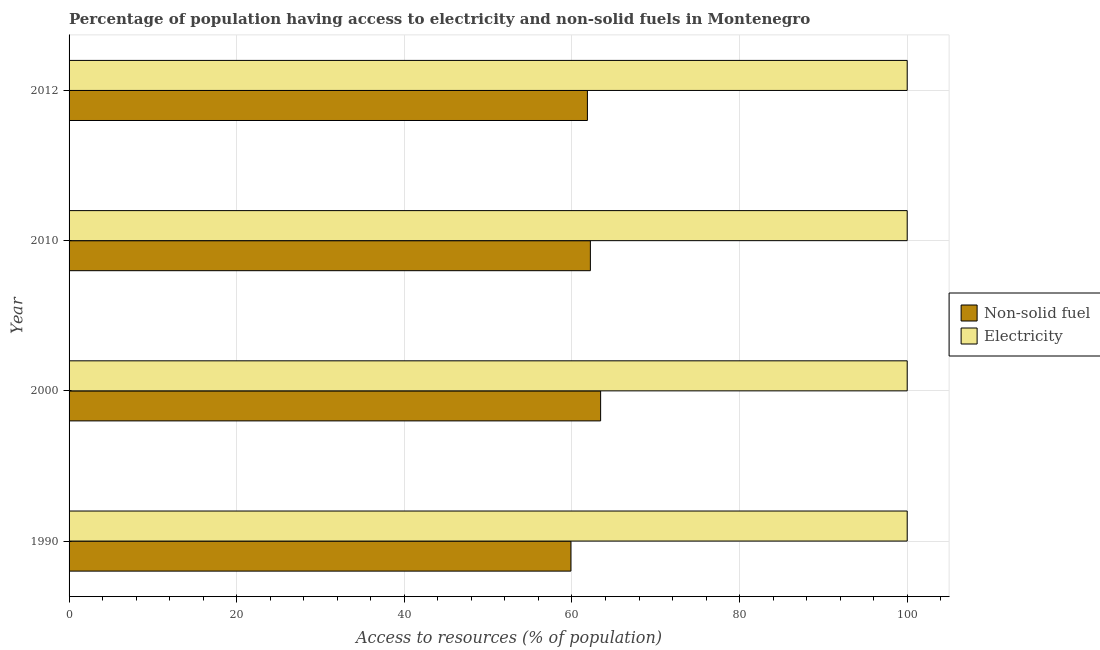Are the number of bars per tick equal to the number of legend labels?
Make the answer very short. Yes. How many bars are there on the 4th tick from the top?
Provide a succinct answer. 2. How many bars are there on the 4th tick from the bottom?
Ensure brevity in your answer.  2. What is the percentage of population having access to electricity in 2010?
Ensure brevity in your answer.  100. Across all years, what is the maximum percentage of population having access to non-solid fuel?
Ensure brevity in your answer.  63.42. Across all years, what is the minimum percentage of population having access to electricity?
Your answer should be compact. 100. What is the total percentage of population having access to electricity in the graph?
Keep it short and to the point. 400. What is the difference between the percentage of population having access to non-solid fuel in 2000 and that in 2010?
Keep it short and to the point. 1.22. What is the difference between the percentage of population having access to electricity in 2012 and the percentage of population having access to non-solid fuel in 2010?
Provide a succinct answer. 37.8. What is the average percentage of population having access to non-solid fuel per year?
Make the answer very short. 61.84. In the year 2010, what is the difference between the percentage of population having access to electricity and percentage of population having access to non-solid fuel?
Your response must be concise. 37.8. What is the ratio of the percentage of population having access to electricity in 1990 to that in 2000?
Your response must be concise. 1. What is the difference between the highest and the second highest percentage of population having access to non-solid fuel?
Your response must be concise. 1.22. What is the difference between the highest and the lowest percentage of population having access to non-solid fuel?
Provide a succinct answer. 3.54. In how many years, is the percentage of population having access to non-solid fuel greater than the average percentage of population having access to non-solid fuel taken over all years?
Provide a succinct answer. 3. What does the 1st bar from the top in 2010 represents?
Make the answer very short. Electricity. What does the 1st bar from the bottom in 2012 represents?
Make the answer very short. Non-solid fuel. Are all the bars in the graph horizontal?
Offer a terse response. Yes. How many years are there in the graph?
Keep it short and to the point. 4. Are the values on the major ticks of X-axis written in scientific E-notation?
Offer a terse response. No. Does the graph contain any zero values?
Your answer should be very brief. No. Does the graph contain grids?
Make the answer very short. Yes. Where does the legend appear in the graph?
Make the answer very short. Center right. How many legend labels are there?
Your answer should be compact. 2. What is the title of the graph?
Keep it short and to the point. Percentage of population having access to electricity and non-solid fuels in Montenegro. Does "Underweight" appear as one of the legend labels in the graph?
Provide a succinct answer. No. What is the label or title of the X-axis?
Ensure brevity in your answer.  Access to resources (% of population). What is the label or title of the Y-axis?
Your response must be concise. Year. What is the Access to resources (% of population) of Non-solid fuel in 1990?
Offer a terse response. 59.88. What is the Access to resources (% of population) in Electricity in 1990?
Ensure brevity in your answer.  100. What is the Access to resources (% of population) of Non-solid fuel in 2000?
Offer a very short reply. 63.42. What is the Access to resources (% of population) of Non-solid fuel in 2010?
Provide a short and direct response. 62.2. What is the Access to resources (% of population) of Non-solid fuel in 2012?
Make the answer very short. 61.85. What is the Access to resources (% of population) in Electricity in 2012?
Keep it short and to the point. 100. Across all years, what is the maximum Access to resources (% of population) of Non-solid fuel?
Keep it short and to the point. 63.42. Across all years, what is the minimum Access to resources (% of population) in Non-solid fuel?
Provide a succinct answer. 59.88. Across all years, what is the minimum Access to resources (% of population) in Electricity?
Give a very brief answer. 100. What is the total Access to resources (% of population) in Non-solid fuel in the graph?
Your answer should be very brief. 247.34. What is the total Access to resources (% of population) of Electricity in the graph?
Provide a succinct answer. 400. What is the difference between the Access to resources (% of population) of Non-solid fuel in 1990 and that in 2000?
Provide a succinct answer. -3.54. What is the difference between the Access to resources (% of population) in Non-solid fuel in 1990 and that in 2010?
Your answer should be very brief. -2.32. What is the difference between the Access to resources (% of population) in Electricity in 1990 and that in 2010?
Make the answer very short. 0. What is the difference between the Access to resources (% of population) of Non-solid fuel in 1990 and that in 2012?
Provide a succinct answer. -1.97. What is the difference between the Access to resources (% of population) in Electricity in 1990 and that in 2012?
Provide a succinct answer. 0. What is the difference between the Access to resources (% of population) in Non-solid fuel in 2000 and that in 2010?
Make the answer very short. 1.22. What is the difference between the Access to resources (% of population) of Electricity in 2000 and that in 2010?
Give a very brief answer. 0. What is the difference between the Access to resources (% of population) of Non-solid fuel in 2000 and that in 2012?
Provide a short and direct response. 1.58. What is the difference between the Access to resources (% of population) in Electricity in 2000 and that in 2012?
Keep it short and to the point. 0. What is the difference between the Access to resources (% of population) in Non-solid fuel in 2010 and that in 2012?
Your answer should be very brief. 0.35. What is the difference between the Access to resources (% of population) of Electricity in 2010 and that in 2012?
Provide a succinct answer. 0. What is the difference between the Access to resources (% of population) in Non-solid fuel in 1990 and the Access to resources (% of population) in Electricity in 2000?
Ensure brevity in your answer.  -40.12. What is the difference between the Access to resources (% of population) of Non-solid fuel in 1990 and the Access to resources (% of population) of Electricity in 2010?
Provide a succinct answer. -40.12. What is the difference between the Access to resources (% of population) in Non-solid fuel in 1990 and the Access to resources (% of population) in Electricity in 2012?
Your response must be concise. -40.12. What is the difference between the Access to resources (% of population) in Non-solid fuel in 2000 and the Access to resources (% of population) in Electricity in 2010?
Ensure brevity in your answer.  -36.58. What is the difference between the Access to resources (% of population) in Non-solid fuel in 2000 and the Access to resources (% of population) in Electricity in 2012?
Your response must be concise. -36.58. What is the difference between the Access to resources (% of population) of Non-solid fuel in 2010 and the Access to resources (% of population) of Electricity in 2012?
Offer a terse response. -37.8. What is the average Access to resources (% of population) of Non-solid fuel per year?
Your answer should be compact. 61.84. In the year 1990, what is the difference between the Access to resources (% of population) in Non-solid fuel and Access to resources (% of population) in Electricity?
Keep it short and to the point. -40.12. In the year 2000, what is the difference between the Access to resources (% of population) in Non-solid fuel and Access to resources (% of population) in Electricity?
Give a very brief answer. -36.58. In the year 2010, what is the difference between the Access to resources (% of population) of Non-solid fuel and Access to resources (% of population) of Electricity?
Your response must be concise. -37.8. In the year 2012, what is the difference between the Access to resources (% of population) of Non-solid fuel and Access to resources (% of population) of Electricity?
Keep it short and to the point. -38.15. What is the ratio of the Access to resources (% of population) of Non-solid fuel in 1990 to that in 2000?
Provide a succinct answer. 0.94. What is the ratio of the Access to resources (% of population) in Non-solid fuel in 1990 to that in 2010?
Your answer should be compact. 0.96. What is the ratio of the Access to resources (% of population) in Non-solid fuel in 1990 to that in 2012?
Your answer should be very brief. 0.97. What is the ratio of the Access to resources (% of population) in Electricity in 1990 to that in 2012?
Provide a succinct answer. 1. What is the ratio of the Access to resources (% of population) of Non-solid fuel in 2000 to that in 2010?
Provide a short and direct response. 1.02. What is the ratio of the Access to resources (% of population) of Non-solid fuel in 2000 to that in 2012?
Provide a succinct answer. 1.03. What is the ratio of the Access to resources (% of population) in Non-solid fuel in 2010 to that in 2012?
Offer a very short reply. 1.01. What is the difference between the highest and the second highest Access to resources (% of population) of Non-solid fuel?
Give a very brief answer. 1.22. What is the difference between the highest and the second highest Access to resources (% of population) in Electricity?
Offer a very short reply. 0. What is the difference between the highest and the lowest Access to resources (% of population) of Non-solid fuel?
Your response must be concise. 3.54. What is the difference between the highest and the lowest Access to resources (% of population) in Electricity?
Provide a succinct answer. 0. 